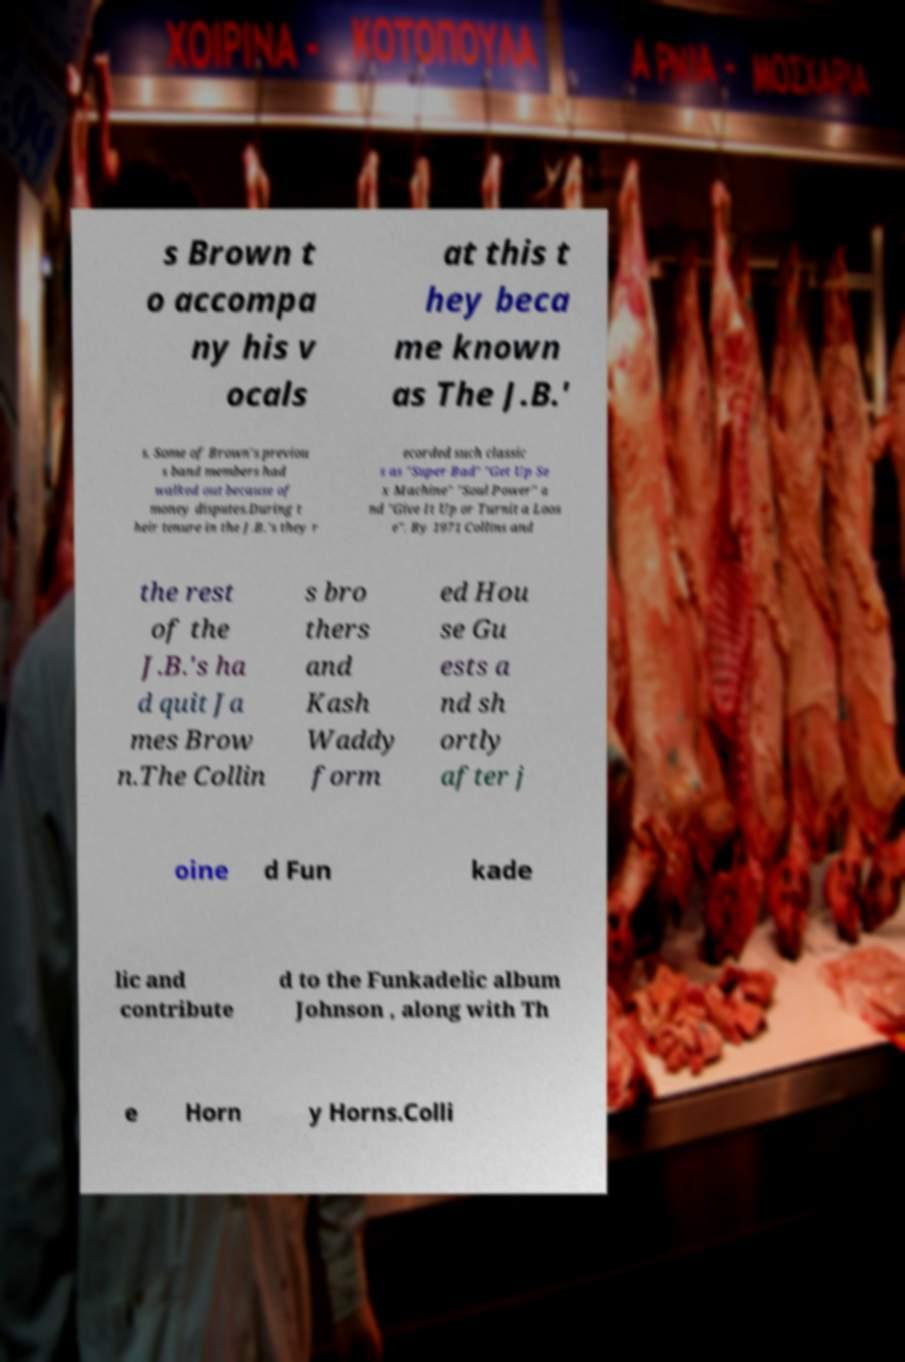Can you accurately transcribe the text from the provided image for me? s Brown t o accompa ny his v ocals at this t hey beca me known as The J.B.' s. Some of Brown's previou s band members had walked out because of money disputes.During t heir tenure in the J.B.'s they r ecorded such classic s as "Super Bad" "Get Up Se x Machine" "Soul Power" a nd "Give It Up or Turnit a Loos e". By 1971 Collins and the rest of the J.B.'s ha d quit Ja mes Brow n.The Collin s bro thers and Kash Waddy form ed Hou se Gu ests a nd sh ortly after j oine d Fun kade lic and contribute d to the Funkadelic album Johnson , along with Th e Horn y Horns.Colli 